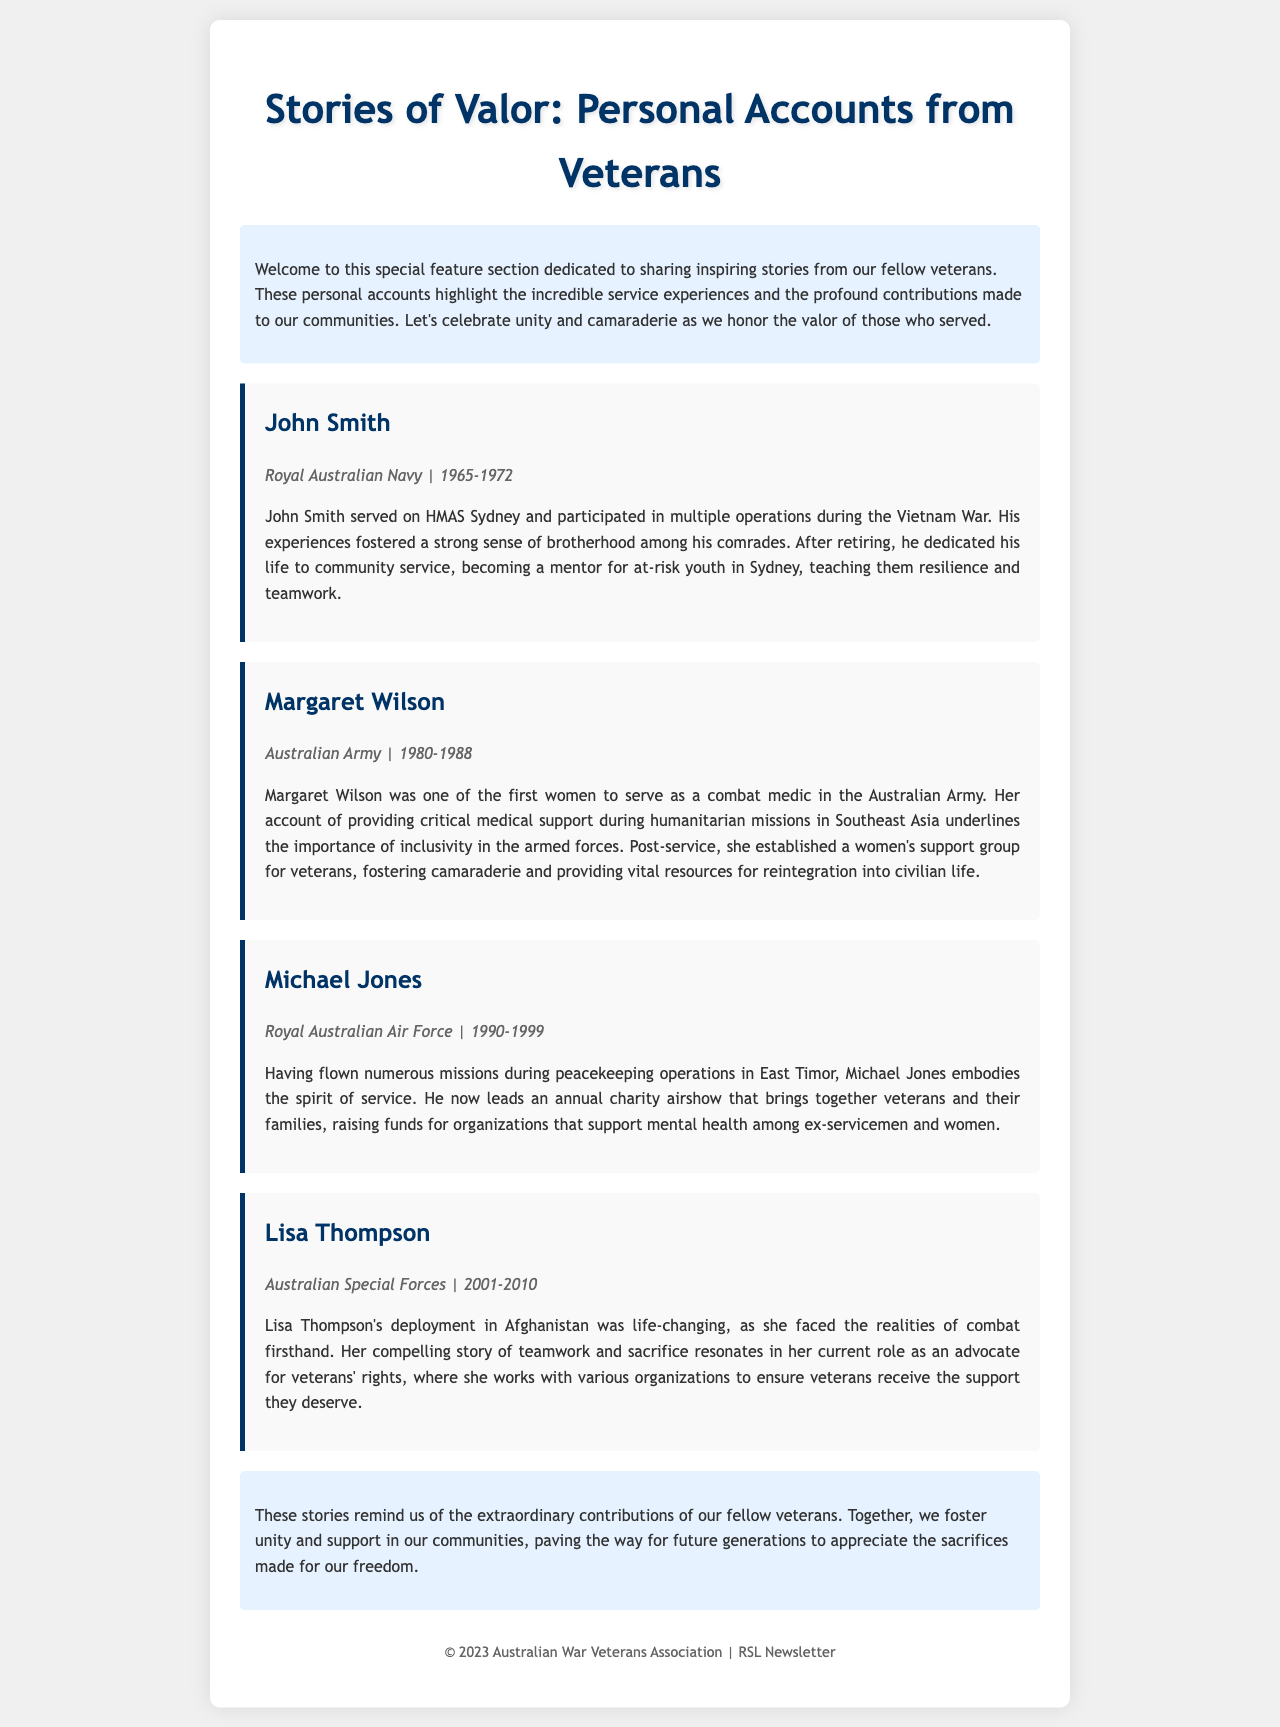What is the title of the feature section? The title of the feature section is prominently displayed at the top of the document.
Answer: Stories of Valor: Personal Accounts from Veterans Who served in the Royal Australian Navy? This information can be found in the personal accounts of veterans.
Answer: John Smith What years did Margaret Wilson serve? The years of service are mentioned in the story details for each veteran.
Answer: 1980-1988 What organization did Michael Jones support through his charity airshow? The document mentions the cause that Michael Jones raises funds for during his event.
Answer: Mental health What role does Lisa Thompson currently hold? The current role of Lisa Thompson is referenced in her story.
Answer: Advocate for veterans' rights How many veterans' stories are featured in the document? The document lists the veterans featured under individual story sections.
Answer: Four 